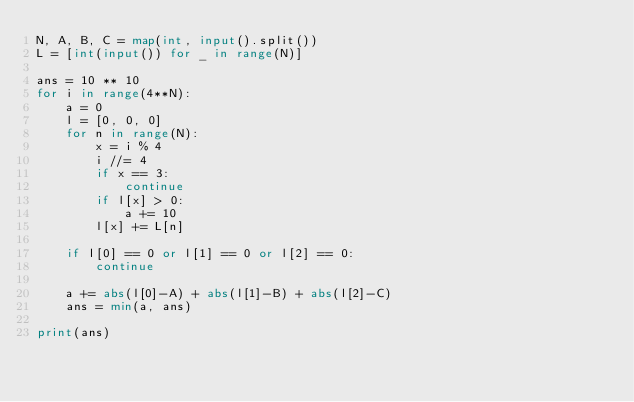<code> <loc_0><loc_0><loc_500><loc_500><_Python_>N, A, B, C = map(int, input().split())
L = [int(input()) for _ in range(N)]

ans = 10 ** 10
for i in range(4**N):
    a = 0
    l = [0, 0, 0]
    for n in range(N):
        x = i % 4
        i //= 4
        if x == 3:
            continue
        if l[x] > 0:
            a += 10
        l[x] += L[n]

    if l[0] == 0 or l[1] == 0 or l[2] == 0:
        continue

    a += abs(l[0]-A) + abs(l[1]-B) + abs(l[2]-C)
    ans = min(a, ans)

print(ans)

</code> 